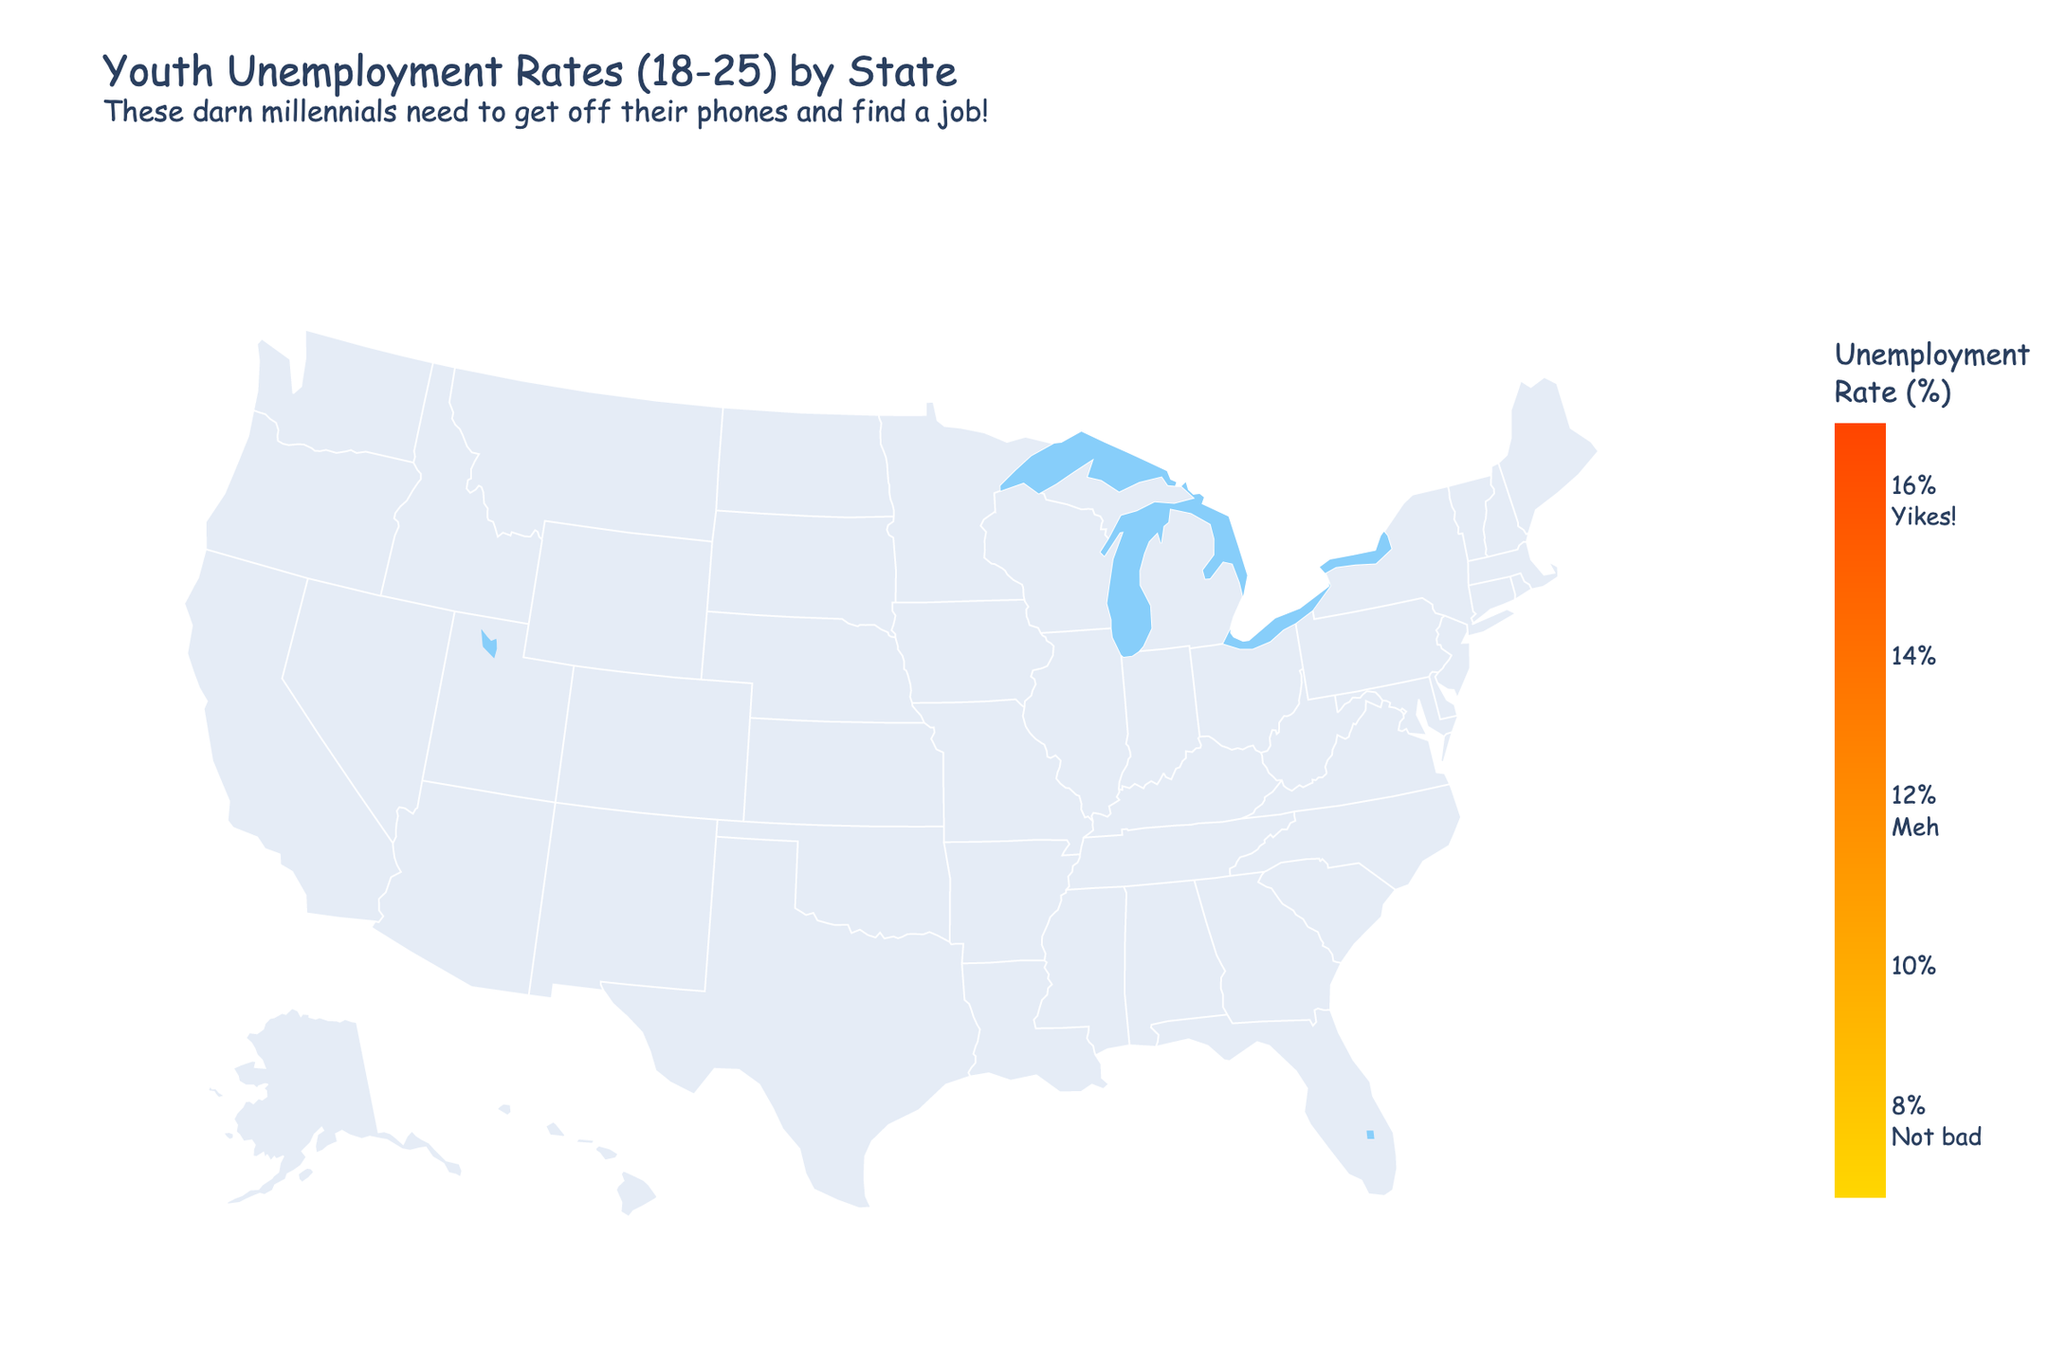What's the title of the figure? The title is usually displayed at the top of the figure, making it easy to spot. The title here is "Youth Unemployment Rates (18-25) by State" followed by a humorous subtitle.
Answer: Youth Unemployment Rates (18-25) by State Which state has the highest unemployment rate among young adults? By scanning the colors on the map and potentially any labels which may indicate the highest value, we see that Mississippi has the highest rate at 16.2%.
Answer: Mississippi Which state has the lowest unemployment rate among young adults? Again, by observing the color gradients and corresponding ranges, North Dakota is the lightest, meaning it has the lowest rate, which is 7.8%.
Answer: North Dakota What's the unemployment rate for young adults in California? Locate California on the map and use the color legend to determine that California's rate is 15.6%.
Answer: 15.6% How many states have an unemployment rate of 10% or lower? Identify states on the map colored in the lighter gradients that correspond to unemployment rates of 10% or lower. Counting them gives us 12 states: Idaho, Iowa, Kansas, Minnesota, Montana, Nebraska, New Hampshire, North Dakota, South Dakota, Utah, Vermont, and Wisconsin.
Answer: 12 What is the average unemployment rate among all states shown? Sum the unemployment rates of all states and divide by the number of states (50). The operation is (12.5 + 14.8 + 11.9 + ... + 10.1 + 9.9)/50. After adding all values together, the sum is 587.2. Dividing by 50 gives an average rate of 11.744%.
Answer: 11.74% Which states have unemployment rates greater than 14%? Using a combination of color-coding and values in the legend, identify the states: Alaska (14.8%), California (15.6%), Georgia (14.2%), Illinois (14.5%), Louisiana (15.1%), Mississippi (16.2%), Nevada (14.7%), New Mexico (15.3%), West Virginia (14.9%).
Answer: Alaska, California, Georgia, Illinois, Louisiana, Mississippi, Nevada, New Mexico, West Virginia What is the difference in the unemployment rates between Florida and Texas? Look up the unemployment rates for Florida (13.8%) and Texas (12.8%). Subtract the smaller value from the larger: 13.8% - 12.8% = 1%.
Answer: 1% Which region (West, Midwest, South, Northeast) appears to have the highest overall unemployment rates? Compare rates visually across regions and note the scales. The South generally appears to have higher rates, based on darker shades in states like Florida, Georgia, and Louisiana.
Answer: South What are the annotations present in the figure? Annotations usually clarify additional information. Here, the annotation at the bottom reads, "Data source: Made-up stats from an old McDonald's manager," indicating the source of the data in a tongue-in-cheek manner.
Answer: Data source: Made-up stats from an old McDonald's manager 